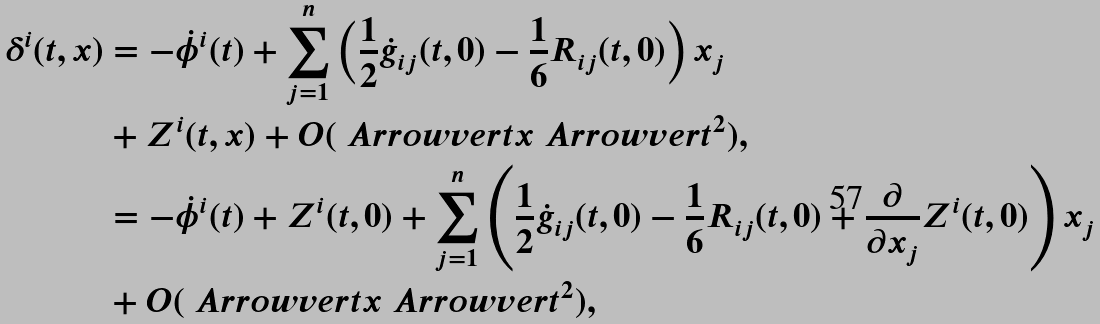<formula> <loc_0><loc_0><loc_500><loc_500>\delta ^ { i } ( t , x ) & = - \dot { \phi } ^ { i } ( t ) + \sum _ { j = 1 } ^ { n } \left ( \frac { 1 } { 2 } \dot { g } _ { i j } ( t , 0 ) - \frac { 1 } { 6 } R _ { i j } ( t , 0 ) \right ) x _ { j } \\ & + Z ^ { i } ( t , x ) + O ( \ A r r o w v e r t x \ A r r o w v e r t ^ { 2 } ) , \\ & = - \dot { \phi } ^ { i } ( t ) + Z ^ { i } ( t , 0 ) + \sum _ { j = 1 } ^ { n } \left ( \frac { 1 } { 2 } \dot { g } _ { i j } ( t , 0 ) - \frac { 1 } { 6 } R _ { i j } ( t , 0 ) + \frac { \partial } { \partial x _ { j } } Z ^ { i } ( t , 0 ) \right ) x _ { j } \\ & + O ( \ A r r o w v e r t x \ A r r o w v e r t ^ { 2 } ) , \\</formula> 